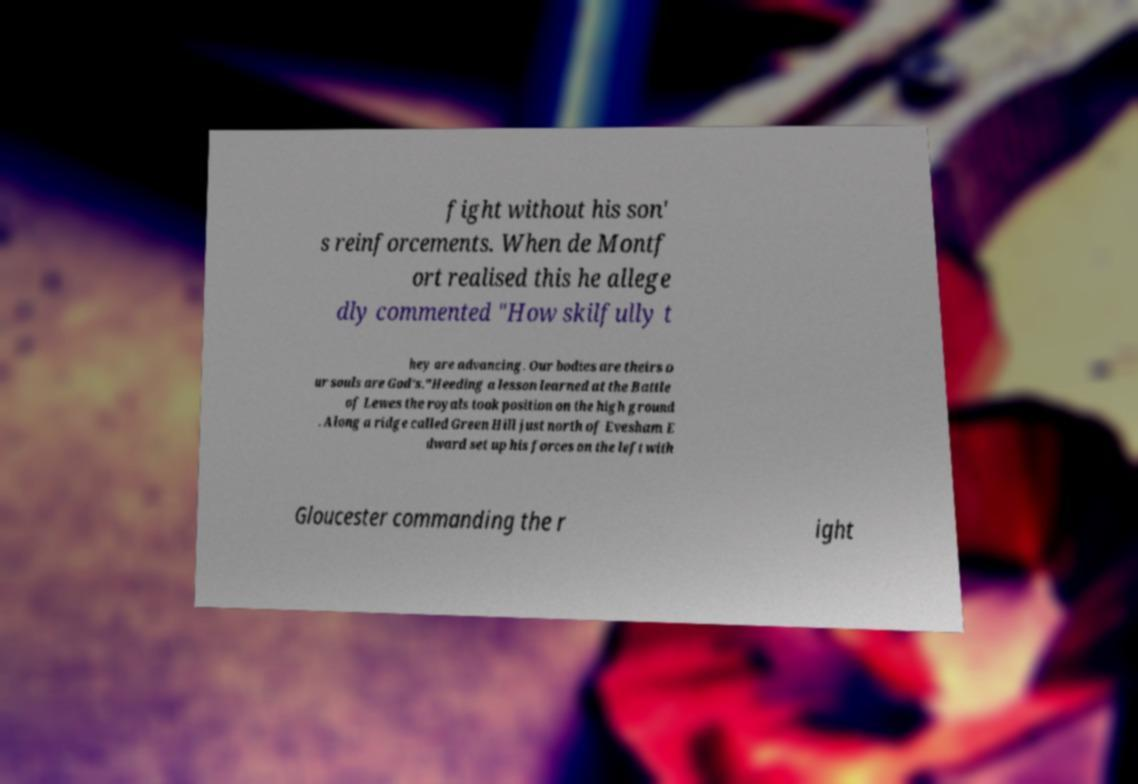Could you assist in decoding the text presented in this image and type it out clearly? fight without his son' s reinforcements. When de Montf ort realised this he allege dly commented "How skilfully t hey are advancing. Our bodies are theirs o ur souls are God's."Heeding a lesson learned at the Battle of Lewes the royals took position on the high ground . Along a ridge called Green Hill just north of Evesham E dward set up his forces on the left with Gloucester commanding the r ight 